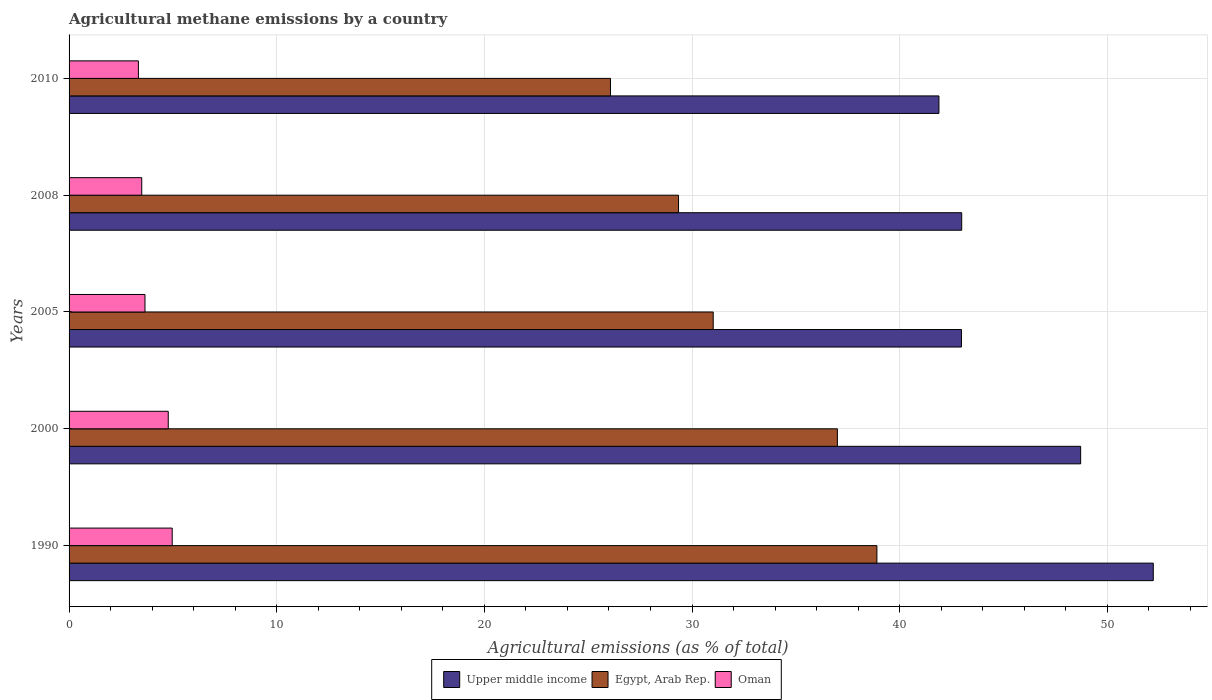How many different coloured bars are there?
Ensure brevity in your answer.  3. Are the number of bars per tick equal to the number of legend labels?
Provide a short and direct response. Yes. How many bars are there on the 2nd tick from the bottom?
Your response must be concise. 3. What is the label of the 3rd group of bars from the top?
Your answer should be very brief. 2005. What is the amount of agricultural methane emitted in Egypt, Arab Rep. in 2010?
Offer a terse response. 26.07. Across all years, what is the maximum amount of agricultural methane emitted in Upper middle income?
Provide a short and direct response. 52.21. Across all years, what is the minimum amount of agricultural methane emitted in Upper middle income?
Your answer should be very brief. 41.89. In which year was the amount of agricultural methane emitted in Egypt, Arab Rep. minimum?
Your answer should be very brief. 2010. What is the total amount of agricultural methane emitted in Upper middle income in the graph?
Make the answer very short. 228.78. What is the difference between the amount of agricultural methane emitted in Oman in 2005 and that in 2008?
Offer a very short reply. 0.16. What is the difference between the amount of agricultural methane emitted in Oman in 2010 and the amount of agricultural methane emitted in Egypt, Arab Rep. in 2008?
Provide a short and direct response. -26.01. What is the average amount of agricultural methane emitted in Egypt, Arab Rep. per year?
Your answer should be compact. 32.47. In the year 2010, what is the difference between the amount of agricultural methane emitted in Oman and amount of agricultural methane emitted in Egypt, Arab Rep.?
Offer a very short reply. -22.73. What is the ratio of the amount of agricultural methane emitted in Upper middle income in 1990 to that in 2010?
Your answer should be very brief. 1.25. Is the difference between the amount of agricultural methane emitted in Oman in 1990 and 2008 greater than the difference between the amount of agricultural methane emitted in Egypt, Arab Rep. in 1990 and 2008?
Provide a succinct answer. No. What is the difference between the highest and the second highest amount of agricultural methane emitted in Upper middle income?
Keep it short and to the point. 3.5. What is the difference between the highest and the lowest amount of agricultural methane emitted in Upper middle income?
Provide a succinct answer. 10.32. In how many years, is the amount of agricultural methane emitted in Upper middle income greater than the average amount of agricultural methane emitted in Upper middle income taken over all years?
Provide a succinct answer. 2. What does the 1st bar from the top in 1990 represents?
Offer a terse response. Oman. What does the 3rd bar from the bottom in 2008 represents?
Ensure brevity in your answer.  Oman. Is it the case that in every year, the sum of the amount of agricultural methane emitted in Upper middle income and amount of agricultural methane emitted in Oman is greater than the amount of agricultural methane emitted in Egypt, Arab Rep.?
Provide a succinct answer. Yes. Are all the bars in the graph horizontal?
Make the answer very short. Yes. How many years are there in the graph?
Provide a succinct answer. 5. Are the values on the major ticks of X-axis written in scientific E-notation?
Offer a terse response. No. Does the graph contain any zero values?
Make the answer very short. No. How many legend labels are there?
Your response must be concise. 3. What is the title of the graph?
Give a very brief answer. Agricultural methane emissions by a country. Does "Cayman Islands" appear as one of the legend labels in the graph?
Give a very brief answer. No. What is the label or title of the X-axis?
Your answer should be very brief. Agricultural emissions (as % of total). What is the label or title of the Y-axis?
Provide a succinct answer. Years. What is the Agricultural emissions (as % of total) in Upper middle income in 1990?
Your answer should be very brief. 52.21. What is the Agricultural emissions (as % of total) in Egypt, Arab Rep. in 1990?
Offer a very short reply. 38.9. What is the Agricultural emissions (as % of total) of Oman in 1990?
Keep it short and to the point. 4.97. What is the Agricultural emissions (as % of total) of Upper middle income in 2000?
Provide a short and direct response. 48.72. What is the Agricultural emissions (as % of total) of Egypt, Arab Rep. in 2000?
Provide a short and direct response. 37. What is the Agricultural emissions (as % of total) in Oman in 2000?
Give a very brief answer. 4.78. What is the Agricultural emissions (as % of total) of Upper middle income in 2005?
Offer a terse response. 42.98. What is the Agricultural emissions (as % of total) in Egypt, Arab Rep. in 2005?
Ensure brevity in your answer.  31.02. What is the Agricultural emissions (as % of total) of Oman in 2005?
Your answer should be very brief. 3.66. What is the Agricultural emissions (as % of total) in Upper middle income in 2008?
Ensure brevity in your answer.  42.99. What is the Agricultural emissions (as % of total) of Egypt, Arab Rep. in 2008?
Ensure brevity in your answer.  29.35. What is the Agricultural emissions (as % of total) in Oman in 2008?
Ensure brevity in your answer.  3.5. What is the Agricultural emissions (as % of total) in Upper middle income in 2010?
Ensure brevity in your answer.  41.89. What is the Agricultural emissions (as % of total) of Egypt, Arab Rep. in 2010?
Give a very brief answer. 26.07. What is the Agricultural emissions (as % of total) of Oman in 2010?
Your answer should be compact. 3.34. Across all years, what is the maximum Agricultural emissions (as % of total) in Upper middle income?
Your response must be concise. 52.21. Across all years, what is the maximum Agricultural emissions (as % of total) in Egypt, Arab Rep.?
Provide a succinct answer. 38.9. Across all years, what is the maximum Agricultural emissions (as % of total) in Oman?
Offer a very short reply. 4.97. Across all years, what is the minimum Agricultural emissions (as % of total) in Upper middle income?
Your answer should be very brief. 41.89. Across all years, what is the minimum Agricultural emissions (as % of total) of Egypt, Arab Rep.?
Provide a short and direct response. 26.07. Across all years, what is the minimum Agricultural emissions (as % of total) in Oman?
Give a very brief answer. 3.34. What is the total Agricultural emissions (as % of total) in Upper middle income in the graph?
Your answer should be very brief. 228.78. What is the total Agricultural emissions (as % of total) in Egypt, Arab Rep. in the graph?
Provide a succinct answer. 162.35. What is the total Agricultural emissions (as % of total) in Oman in the graph?
Your answer should be very brief. 20.24. What is the difference between the Agricultural emissions (as % of total) in Upper middle income in 1990 and that in 2000?
Your answer should be compact. 3.5. What is the difference between the Agricultural emissions (as % of total) of Egypt, Arab Rep. in 1990 and that in 2000?
Make the answer very short. 1.9. What is the difference between the Agricultural emissions (as % of total) of Oman in 1990 and that in 2000?
Provide a succinct answer. 0.19. What is the difference between the Agricultural emissions (as % of total) in Upper middle income in 1990 and that in 2005?
Provide a short and direct response. 9.24. What is the difference between the Agricultural emissions (as % of total) of Egypt, Arab Rep. in 1990 and that in 2005?
Provide a succinct answer. 7.88. What is the difference between the Agricultural emissions (as % of total) in Oman in 1990 and that in 2005?
Keep it short and to the point. 1.31. What is the difference between the Agricultural emissions (as % of total) of Upper middle income in 1990 and that in 2008?
Ensure brevity in your answer.  9.23. What is the difference between the Agricultural emissions (as % of total) of Egypt, Arab Rep. in 1990 and that in 2008?
Your answer should be compact. 9.55. What is the difference between the Agricultural emissions (as % of total) in Oman in 1990 and that in 2008?
Make the answer very short. 1.47. What is the difference between the Agricultural emissions (as % of total) in Upper middle income in 1990 and that in 2010?
Your response must be concise. 10.32. What is the difference between the Agricultural emissions (as % of total) in Egypt, Arab Rep. in 1990 and that in 2010?
Provide a short and direct response. 12.83. What is the difference between the Agricultural emissions (as % of total) of Oman in 1990 and that in 2010?
Your answer should be compact. 1.63. What is the difference between the Agricultural emissions (as % of total) of Upper middle income in 2000 and that in 2005?
Give a very brief answer. 5.74. What is the difference between the Agricultural emissions (as % of total) in Egypt, Arab Rep. in 2000 and that in 2005?
Provide a succinct answer. 5.98. What is the difference between the Agricultural emissions (as % of total) of Oman in 2000 and that in 2005?
Your answer should be compact. 1.12. What is the difference between the Agricultural emissions (as % of total) of Upper middle income in 2000 and that in 2008?
Keep it short and to the point. 5.73. What is the difference between the Agricultural emissions (as % of total) of Egypt, Arab Rep. in 2000 and that in 2008?
Your answer should be very brief. 7.65. What is the difference between the Agricultural emissions (as % of total) of Oman in 2000 and that in 2008?
Your answer should be compact. 1.28. What is the difference between the Agricultural emissions (as % of total) of Upper middle income in 2000 and that in 2010?
Offer a terse response. 6.82. What is the difference between the Agricultural emissions (as % of total) in Egypt, Arab Rep. in 2000 and that in 2010?
Give a very brief answer. 10.93. What is the difference between the Agricultural emissions (as % of total) in Oman in 2000 and that in 2010?
Offer a very short reply. 1.44. What is the difference between the Agricultural emissions (as % of total) of Upper middle income in 2005 and that in 2008?
Ensure brevity in your answer.  -0.01. What is the difference between the Agricultural emissions (as % of total) of Egypt, Arab Rep. in 2005 and that in 2008?
Ensure brevity in your answer.  1.67. What is the difference between the Agricultural emissions (as % of total) in Oman in 2005 and that in 2008?
Your answer should be very brief. 0.16. What is the difference between the Agricultural emissions (as % of total) of Upper middle income in 2005 and that in 2010?
Provide a short and direct response. 1.08. What is the difference between the Agricultural emissions (as % of total) of Egypt, Arab Rep. in 2005 and that in 2010?
Keep it short and to the point. 4.95. What is the difference between the Agricultural emissions (as % of total) of Oman in 2005 and that in 2010?
Your answer should be compact. 0.32. What is the difference between the Agricultural emissions (as % of total) in Upper middle income in 2008 and that in 2010?
Your response must be concise. 1.1. What is the difference between the Agricultural emissions (as % of total) in Egypt, Arab Rep. in 2008 and that in 2010?
Offer a very short reply. 3.28. What is the difference between the Agricultural emissions (as % of total) of Oman in 2008 and that in 2010?
Give a very brief answer. 0.16. What is the difference between the Agricultural emissions (as % of total) in Upper middle income in 1990 and the Agricultural emissions (as % of total) in Egypt, Arab Rep. in 2000?
Offer a very short reply. 15.21. What is the difference between the Agricultural emissions (as % of total) in Upper middle income in 1990 and the Agricultural emissions (as % of total) in Oman in 2000?
Your response must be concise. 47.44. What is the difference between the Agricultural emissions (as % of total) of Egypt, Arab Rep. in 1990 and the Agricultural emissions (as % of total) of Oman in 2000?
Provide a short and direct response. 34.13. What is the difference between the Agricultural emissions (as % of total) of Upper middle income in 1990 and the Agricultural emissions (as % of total) of Egypt, Arab Rep. in 2005?
Your answer should be very brief. 21.19. What is the difference between the Agricultural emissions (as % of total) in Upper middle income in 1990 and the Agricultural emissions (as % of total) in Oman in 2005?
Your response must be concise. 48.56. What is the difference between the Agricultural emissions (as % of total) in Egypt, Arab Rep. in 1990 and the Agricultural emissions (as % of total) in Oman in 2005?
Your answer should be very brief. 35.25. What is the difference between the Agricultural emissions (as % of total) in Upper middle income in 1990 and the Agricultural emissions (as % of total) in Egypt, Arab Rep. in 2008?
Offer a very short reply. 22.86. What is the difference between the Agricultural emissions (as % of total) in Upper middle income in 1990 and the Agricultural emissions (as % of total) in Oman in 2008?
Offer a very short reply. 48.71. What is the difference between the Agricultural emissions (as % of total) in Egypt, Arab Rep. in 1990 and the Agricultural emissions (as % of total) in Oman in 2008?
Offer a very short reply. 35.4. What is the difference between the Agricultural emissions (as % of total) in Upper middle income in 1990 and the Agricultural emissions (as % of total) in Egypt, Arab Rep. in 2010?
Make the answer very short. 26.14. What is the difference between the Agricultural emissions (as % of total) in Upper middle income in 1990 and the Agricultural emissions (as % of total) in Oman in 2010?
Give a very brief answer. 48.88. What is the difference between the Agricultural emissions (as % of total) of Egypt, Arab Rep. in 1990 and the Agricultural emissions (as % of total) of Oman in 2010?
Your answer should be compact. 35.57. What is the difference between the Agricultural emissions (as % of total) in Upper middle income in 2000 and the Agricultural emissions (as % of total) in Egypt, Arab Rep. in 2005?
Offer a terse response. 17.7. What is the difference between the Agricultural emissions (as % of total) in Upper middle income in 2000 and the Agricultural emissions (as % of total) in Oman in 2005?
Provide a short and direct response. 45.06. What is the difference between the Agricultural emissions (as % of total) of Egypt, Arab Rep. in 2000 and the Agricultural emissions (as % of total) of Oman in 2005?
Ensure brevity in your answer.  33.34. What is the difference between the Agricultural emissions (as % of total) of Upper middle income in 2000 and the Agricultural emissions (as % of total) of Egypt, Arab Rep. in 2008?
Give a very brief answer. 19.37. What is the difference between the Agricultural emissions (as % of total) in Upper middle income in 2000 and the Agricultural emissions (as % of total) in Oman in 2008?
Offer a very short reply. 45.22. What is the difference between the Agricultural emissions (as % of total) of Egypt, Arab Rep. in 2000 and the Agricultural emissions (as % of total) of Oman in 2008?
Offer a very short reply. 33.5. What is the difference between the Agricultural emissions (as % of total) in Upper middle income in 2000 and the Agricultural emissions (as % of total) in Egypt, Arab Rep. in 2010?
Offer a terse response. 22.64. What is the difference between the Agricultural emissions (as % of total) in Upper middle income in 2000 and the Agricultural emissions (as % of total) in Oman in 2010?
Give a very brief answer. 45.38. What is the difference between the Agricultural emissions (as % of total) in Egypt, Arab Rep. in 2000 and the Agricultural emissions (as % of total) in Oman in 2010?
Make the answer very short. 33.66. What is the difference between the Agricultural emissions (as % of total) in Upper middle income in 2005 and the Agricultural emissions (as % of total) in Egypt, Arab Rep. in 2008?
Provide a short and direct response. 13.62. What is the difference between the Agricultural emissions (as % of total) in Upper middle income in 2005 and the Agricultural emissions (as % of total) in Oman in 2008?
Make the answer very short. 39.48. What is the difference between the Agricultural emissions (as % of total) of Egypt, Arab Rep. in 2005 and the Agricultural emissions (as % of total) of Oman in 2008?
Provide a short and direct response. 27.52. What is the difference between the Agricultural emissions (as % of total) in Upper middle income in 2005 and the Agricultural emissions (as % of total) in Egypt, Arab Rep. in 2010?
Make the answer very short. 16.9. What is the difference between the Agricultural emissions (as % of total) in Upper middle income in 2005 and the Agricultural emissions (as % of total) in Oman in 2010?
Offer a very short reply. 39.64. What is the difference between the Agricultural emissions (as % of total) of Egypt, Arab Rep. in 2005 and the Agricultural emissions (as % of total) of Oman in 2010?
Provide a succinct answer. 27.68. What is the difference between the Agricultural emissions (as % of total) of Upper middle income in 2008 and the Agricultural emissions (as % of total) of Egypt, Arab Rep. in 2010?
Offer a very short reply. 16.91. What is the difference between the Agricultural emissions (as % of total) of Upper middle income in 2008 and the Agricultural emissions (as % of total) of Oman in 2010?
Your response must be concise. 39.65. What is the difference between the Agricultural emissions (as % of total) in Egypt, Arab Rep. in 2008 and the Agricultural emissions (as % of total) in Oman in 2010?
Keep it short and to the point. 26.01. What is the average Agricultural emissions (as % of total) in Upper middle income per year?
Offer a terse response. 45.76. What is the average Agricultural emissions (as % of total) in Egypt, Arab Rep. per year?
Give a very brief answer. 32.47. What is the average Agricultural emissions (as % of total) in Oman per year?
Offer a terse response. 4.05. In the year 1990, what is the difference between the Agricultural emissions (as % of total) in Upper middle income and Agricultural emissions (as % of total) in Egypt, Arab Rep.?
Your answer should be very brief. 13.31. In the year 1990, what is the difference between the Agricultural emissions (as % of total) in Upper middle income and Agricultural emissions (as % of total) in Oman?
Your answer should be very brief. 47.25. In the year 1990, what is the difference between the Agricultural emissions (as % of total) of Egypt, Arab Rep. and Agricultural emissions (as % of total) of Oman?
Your response must be concise. 33.94. In the year 2000, what is the difference between the Agricultural emissions (as % of total) of Upper middle income and Agricultural emissions (as % of total) of Egypt, Arab Rep.?
Provide a short and direct response. 11.72. In the year 2000, what is the difference between the Agricultural emissions (as % of total) of Upper middle income and Agricultural emissions (as % of total) of Oman?
Keep it short and to the point. 43.94. In the year 2000, what is the difference between the Agricultural emissions (as % of total) of Egypt, Arab Rep. and Agricultural emissions (as % of total) of Oman?
Offer a very short reply. 32.22. In the year 2005, what is the difference between the Agricultural emissions (as % of total) of Upper middle income and Agricultural emissions (as % of total) of Egypt, Arab Rep.?
Your answer should be very brief. 11.96. In the year 2005, what is the difference between the Agricultural emissions (as % of total) of Upper middle income and Agricultural emissions (as % of total) of Oman?
Provide a short and direct response. 39.32. In the year 2005, what is the difference between the Agricultural emissions (as % of total) of Egypt, Arab Rep. and Agricultural emissions (as % of total) of Oman?
Your answer should be very brief. 27.36. In the year 2008, what is the difference between the Agricultural emissions (as % of total) in Upper middle income and Agricultural emissions (as % of total) in Egypt, Arab Rep.?
Provide a short and direct response. 13.64. In the year 2008, what is the difference between the Agricultural emissions (as % of total) in Upper middle income and Agricultural emissions (as % of total) in Oman?
Give a very brief answer. 39.49. In the year 2008, what is the difference between the Agricultural emissions (as % of total) of Egypt, Arab Rep. and Agricultural emissions (as % of total) of Oman?
Make the answer very short. 25.85. In the year 2010, what is the difference between the Agricultural emissions (as % of total) of Upper middle income and Agricultural emissions (as % of total) of Egypt, Arab Rep.?
Your response must be concise. 15.82. In the year 2010, what is the difference between the Agricultural emissions (as % of total) in Upper middle income and Agricultural emissions (as % of total) in Oman?
Provide a succinct answer. 38.55. In the year 2010, what is the difference between the Agricultural emissions (as % of total) in Egypt, Arab Rep. and Agricultural emissions (as % of total) in Oman?
Your response must be concise. 22.73. What is the ratio of the Agricultural emissions (as % of total) in Upper middle income in 1990 to that in 2000?
Keep it short and to the point. 1.07. What is the ratio of the Agricultural emissions (as % of total) in Egypt, Arab Rep. in 1990 to that in 2000?
Make the answer very short. 1.05. What is the ratio of the Agricultural emissions (as % of total) in Oman in 1990 to that in 2000?
Provide a succinct answer. 1.04. What is the ratio of the Agricultural emissions (as % of total) in Upper middle income in 1990 to that in 2005?
Your response must be concise. 1.22. What is the ratio of the Agricultural emissions (as % of total) of Egypt, Arab Rep. in 1990 to that in 2005?
Your response must be concise. 1.25. What is the ratio of the Agricultural emissions (as % of total) in Oman in 1990 to that in 2005?
Provide a succinct answer. 1.36. What is the ratio of the Agricultural emissions (as % of total) in Upper middle income in 1990 to that in 2008?
Make the answer very short. 1.21. What is the ratio of the Agricultural emissions (as % of total) of Egypt, Arab Rep. in 1990 to that in 2008?
Ensure brevity in your answer.  1.33. What is the ratio of the Agricultural emissions (as % of total) of Oman in 1990 to that in 2008?
Offer a very short reply. 1.42. What is the ratio of the Agricultural emissions (as % of total) of Upper middle income in 1990 to that in 2010?
Your answer should be compact. 1.25. What is the ratio of the Agricultural emissions (as % of total) in Egypt, Arab Rep. in 1990 to that in 2010?
Make the answer very short. 1.49. What is the ratio of the Agricultural emissions (as % of total) in Oman in 1990 to that in 2010?
Offer a terse response. 1.49. What is the ratio of the Agricultural emissions (as % of total) of Upper middle income in 2000 to that in 2005?
Provide a short and direct response. 1.13. What is the ratio of the Agricultural emissions (as % of total) of Egypt, Arab Rep. in 2000 to that in 2005?
Make the answer very short. 1.19. What is the ratio of the Agricultural emissions (as % of total) in Oman in 2000 to that in 2005?
Make the answer very short. 1.31. What is the ratio of the Agricultural emissions (as % of total) in Upper middle income in 2000 to that in 2008?
Offer a very short reply. 1.13. What is the ratio of the Agricultural emissions (as % of total) in Egypt, Arab Rep. in 2000 to that in 2008?
Provide a succinct answer. 1.26. What is the ratio of the Agricultural emissions (as % of total) in Oman in 2000 to that in 2008?
Offer a very short reply. 1.36. What is the ratio of the Agricultural emissions (as % of total) of Upper middle income in 2000 to that in 2010?
Your answer should be compact. 1.16. What is the ratio of the Agricultural emissions (as % of total) in Egypt, Arab Rep. in 2000 to that in 2010?
Give a very brief answer. 1.42. What is the ratio of the Agricultural emissions (as % of total) in Oman in 2000 to that in 2010?
Provide a short and direct response. 1.43. What is the ratio of the Agricultural emissions (as % of total) in Upper middle income in 2005 to that in 2008?
Provide a short and direct response. 1. What is the ratio of the Agricultural emissions (as % of total) in Egypt, Arab Rep. in 2005 to that in 2008?
Give a very brief answer. 1.06. What is the ratio of the Agricultural emissions (as % of total) of Oman in 2005 to that in 2008?
Your response must be concise. 1.04. What is the ratio of the Agricultural emissions (as % of total) of Upper middle income in 2005 to that in 2010?
Ensure brevity in your answer.  1.03. What is the ratio of the Agricultural emissions (as % of total) of Egypt, Arab Rep. in 2005 to that in 2010?
Provide a short and direct response. 1.19. What is the ratio of the Agricultural emissions (as % of total) in Oman in 2005 to that in 2010?
Provide a short and direct response. 1.09. What is the ratio of the Agricultural emissions (as % of total) of Upper middle income in 2008 to that in 2010?
Your answer should be compact. 1.03. What is the ratio of the Agricultural emissions (as % of total) in Egypt, Arab Rep. in 2008 to that in 2010?
Your answer should be compact. 1.13. What is the ratio of the Agricultural emissions (as % of total) in Oman in 2008 to that in 2010?
Provide a short and direct response. 1.05. What is the difference between the highest and the second highest Agricultural emissions (as % of total) in Upper middle income?
Your answer should be very brief. 3.5. What is the difference between the highest and the second highest Agricultural emissions (as % of total) of Egypt, Arab Rep.?
Your response must be concise. 1.9. What is the difference between the highest and the second highest Agricultural emissions (as % of total) in Oman?
Your response must be concise. 0.19. What is the difference between the highest and the lowest Agricultural emissions (as % of total) of Upper middle income?
Provide a succinct answer. 10.32. What is the difference between the highest and the lowest Agricultural emissions (as % of total) of Egypt, Arab Rep.?
Your answer should be very brief. 12.83. What is the difference between the highest and the lowest Agricultural emissions (as % of total) of Oman?
Make the answer very short. 1.63. 